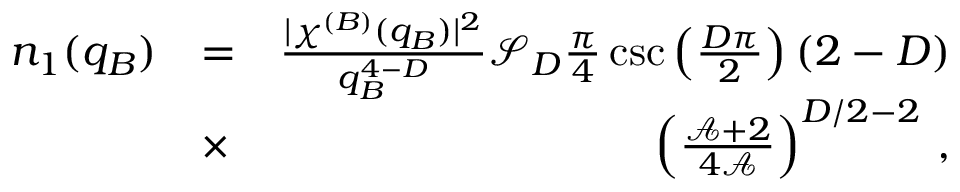Convert formula to latex. <formula><loc_0><loc_0><loc_500><loc_500>\begin{array} { r l r } { n _ { 1 } ( q _ { B } ) } & { = } & { \frac { | \chi ^ { ( B ) } ( q _ { B } ) | ^ { 2 } } { q _ { B } ^ { 4 - D } } \mathcal { S } _ { D } \frac { \pi } { 4 } \csc \left ( \frac { D \pi } { 2 } \right ) ( 2 - D ) } \\ & { \times } & { \left ( \frac { \mathcal { A } + 2 } { 4 \mathcal { A } } \right ) ^ { D / 2 - 2 } \, , } \end{array}</formula> 